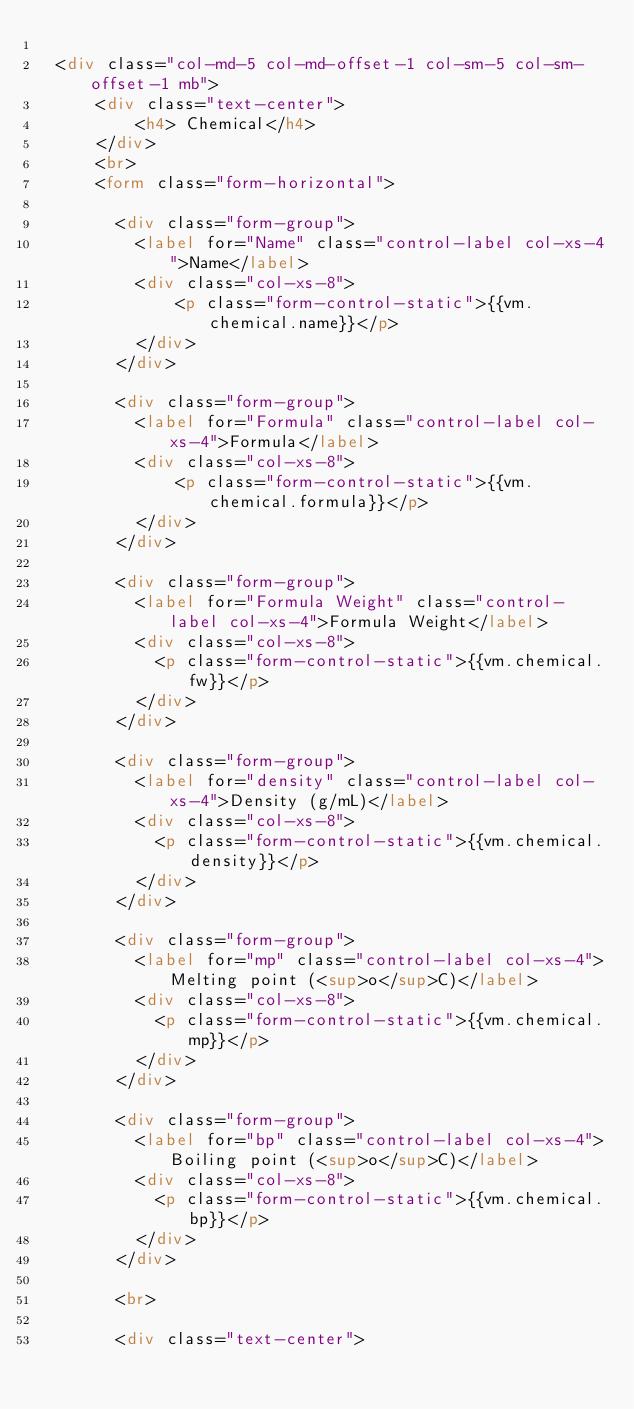Convert code to text. <code><loc_0><loc_0><loc_500><loc_500><_HTML_>
  <div class="col-md-5 col-md-offset-1 col-sm-5 col-sm-offset-1 mb">
      <div class="text-center">
          <h4> Chemical</h4>
      </div>
      <br>
      <form class="form-horizontal">

        <div class="form-group">
          <label for="Name" class="control-label col-xs-4">Name</label>
          <div class="col-xs-8">
              <p class="form-control-static">{{vm.chemical.name}}</p>
          </div>
        </div>

        <div class="form-group">
          <label for="Formula" class="control-label col-xs-4">Formula</label>
          <div class="col-xs-8">
              <p class="form-control-static">{{vm.chemical.formula}}</p>
          </div>
        </div>

        <div class="form-group">
          <label for="Formula Weight" class="control-label col-xs-4">Formula Weight</label>
          <div class="col-xs-8">
            <p class="form-control-static">{{vm.chemical.fw}}</p>
          </div>
        </div>

        <div class="form-group">
          <label for="density" class="control-label col-xs-4">Density (g/mL)</label>
          <div class="col-xs-8">
            <p class="form-control-static">{{vm.chemical.density}}</p>
          </div>
        </div>

        <div class="form-group">
          <label for="mp" class="control-label col-xs-4">Melting point (<sup>o</sup>C)</label>
          <div class="col-xs-8">
            <p class="form-control-static">{{vm.chemical.mp}}</p>
          </div>
        </div>

        <div class="form-group">
          <label for="bp" class="control-label col-xs-4">Boiling point (<sup>o</sup>C)</label>
          <div class="col-xs-8">
            <p class="form-control-static">{{vm.chemical.bp}}</p>
          </div>
        </div>

        <br>

        <div class="text-center"></code> 